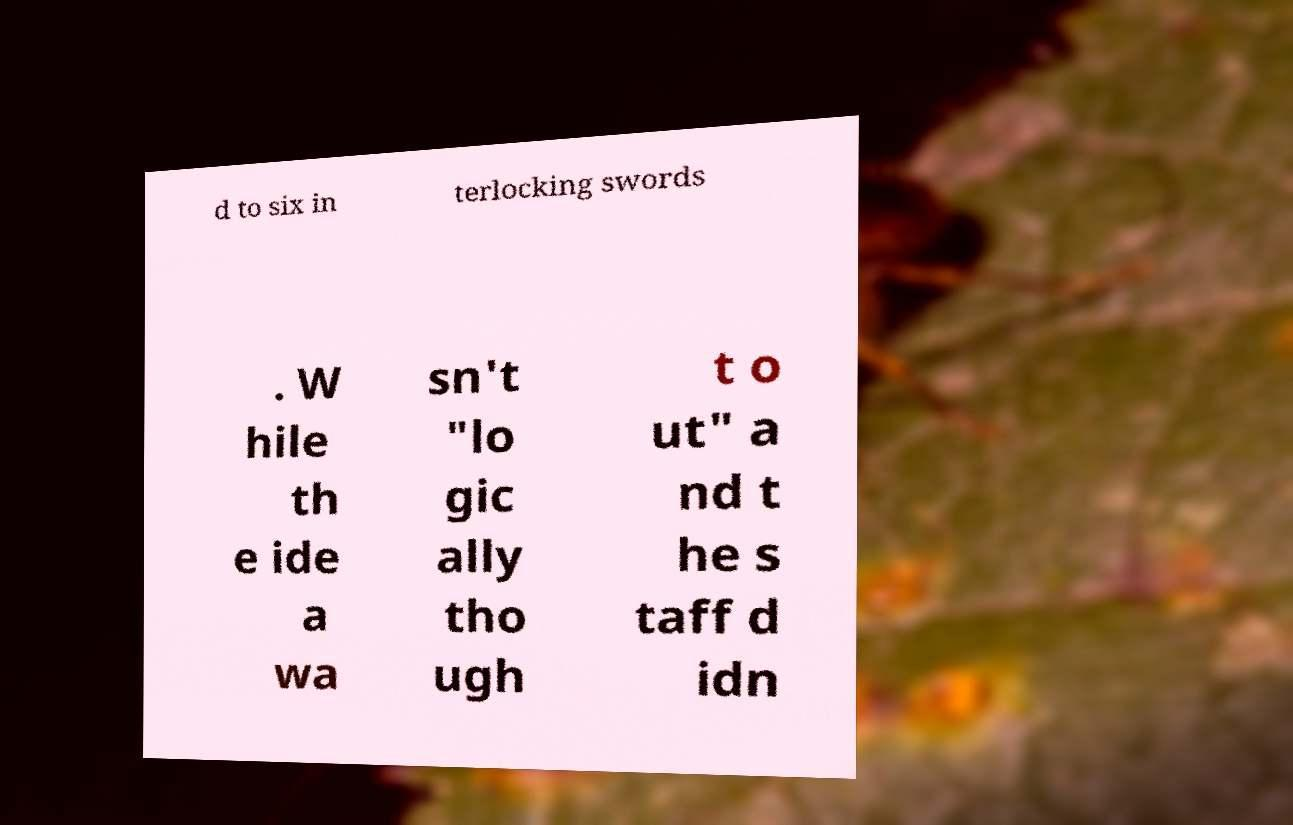Can you accurately transcribe the text from the provided image for me? d to six in terlocking swords . W hile th e ide a wa sn't "lo gic ally tho ugh t o ut" a nd t he s taff d idn 